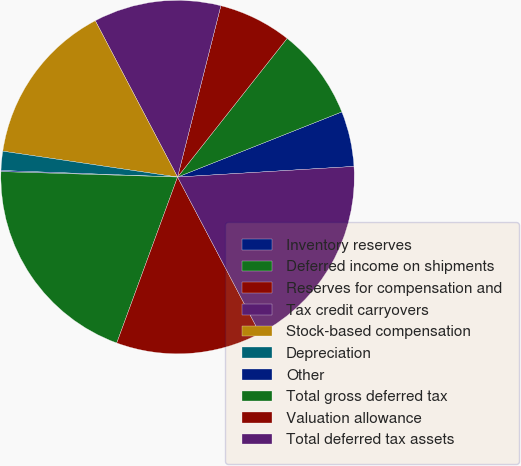Convert chart. <chart><loc_0><loc_0><loc_500><loc_500><pie_chart><fcel>Inventory reserves<fcel>Deferred income on shipments<fcel>Reserves for compensation and<fcel>Tax credit carryovers<fcel>Stock-based compensation<fcel>Depreciation<fcel>Other<fcel>Total gross deferred tax<fcel>Valuation allowance<fcel>Total deferred tax assets<nl><fcel>5.05%<fcel>8.35%<fcel>6.7%<fcel>11.65%<fcel>14.95%<fcel>1.75%<fcel>0.1%<fcel>19.9%<fcel>13.3%<fcel>18.25%<nl></chart> 